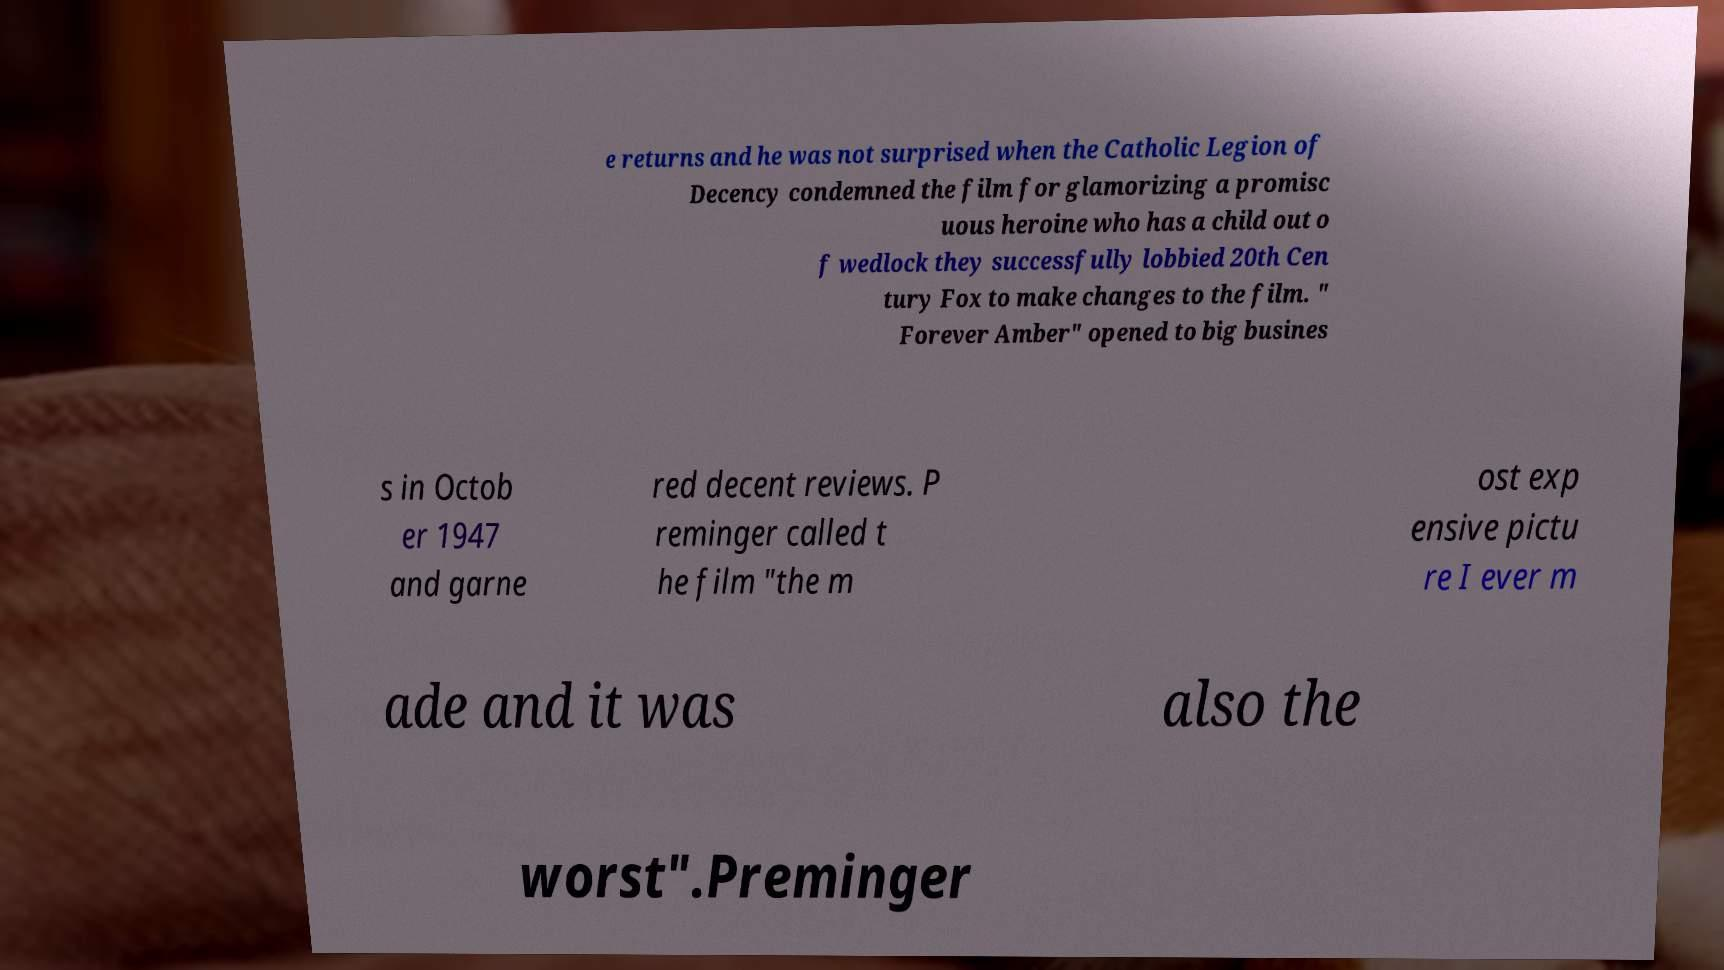There's text embedded in this image that I need extracted. Can you transcribe it verbatim? e returns and he was not surprised when the Catholic Legion of Decency condemned the film for glamorizing a promisc uous heroine who has a child out o f wedlock they successfully lobbied 20th Cen tury Fox to make changes to the film. " Forever Amber" opened to big busines s in Octob er 1947 and garne red decent reviews. P reminger called t he film "the m ost exp ensive pictu re I ever m ade and it was also the worst".Preminger 